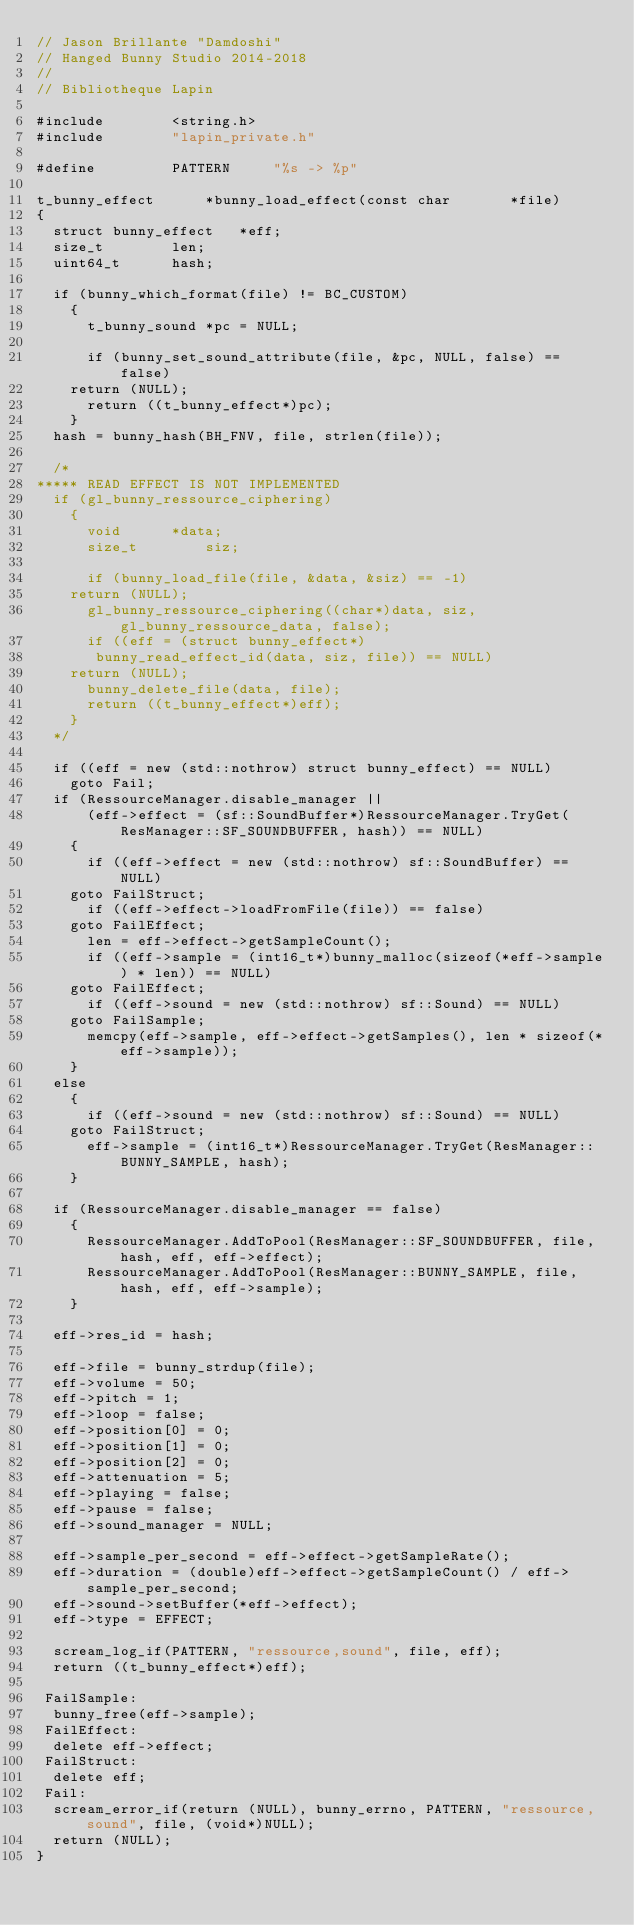<code> <loc_0><loc_0><loc_500><loc_500><_C++_>// Jason Brillante "Damdoshi"
// Hanged Bunny Studio 2014-2018
//
// Bibliotheque Lapin

#include		<string.h>
#include		"lapin_private.h"

#define			PATTERN		"%s -> %p"

t_bunny_effect		*bunny_load_effect(const char		*file)
{
  struct bunny_effect	*eff;
  size_t		len;
  uint64_t		hash;

  if (bunny_which_format(file) != BC_CUSTOM)
    {
      t_bunny_sound	*pc = NULL;

      if (bunny_set_sound_attribute(file, &pc, NULL, false) == false)
	return (NULL);
      return ((t_bunny_effect*)pc);
    }
  hash = bunny_hash(BH_FNV, file, strlen(file));

  /*
***** READ EFFECT IS NOT IMPLEMENTED
  if (gl_bunny_ressource_ciphering)
    {
      void		*data;
      size_t		siz;

      if (bunny_load_file(file, &data, &siz) == -1)
	return (NULL);
      gl_bunny_ressource_ciphering((char*)data, siz, gl_bunny_ressource_data, false);
      if ((eff = (struct bunny_effect*)
	   bunny_read_effect_id(data, siz, file)) == NULL)
	return (NULL);
      bunny_delete_file(data, file);
      return ((t_bunny_effect*)eff);
    }
  */

  if ((eff = new (std::nothrow) struct bunny_effect) == NULL)
    goto Fail;
  if (RessourceManager.disable_manager ||
      (eff->effect = (sf::SoundBuffer*)RessourceManager.TryGet(ResManager::SF_SOUNDBUFFER, hash)) == NULL)
    {
      if ((eff->effect = new (std::nothrow) sf::SoundBuffer) == NULL)
	goto FailStruct;
      if ((eff->effect->loadFromFile(file)) == false)
	goto FailEffect;
      len = eff->effect->getSampleCount();
      if ((eff->sample = (int16_t*)bunny_malloc(sizeof(*eff->sample) * len)) == NULL)
	goto FailEffect;
      if ((eff->sound = new (std::nothrow) sf::Sound) == NULL)
	goto FailSample;
      memcpy(eff->sample, eff->effect->getSamples(), len * sizeof(*eff->sample));
    }
  else
    {
      if ((eff->sound = new (std::nothrow) sf::Sound) == NULL)
	goto FailStruct;
      eff->sample = (int16_t*)RessourceManager.TryGet(ResManager::BUNNY_SAMPLE, hash);
    }

  if (RessourceManager.disable_manager == false)
    {
      RessourceManager.AddToPool(ResManager::SF_SOUNDBUFFER, file, hash, eff, eff->effect);
      RessourceManager.AddToPool(ResManager::BUNNY_SAMPLE, file, hash, eff, eff->sample);
    }

  eff->res_id = hash;

  eff->file = bunny_strdup(file);
  eff->volume = 50;
  eff->pitch = 1;
  eff->loop = false;
  eff->position[0] = 0;
  eff->position[1] = 0;
  eff->position[2] = 0;
  eff->attenuation = 5;
  eff->playing = false;
  eff->pause = false;
  eff->sound_manager = NULL;

  eff->sample_per_second = eff->effect->getSampleRate();
  eff->duration = (double)eff->effect->getSampleCount() / eff->sample_per_second;
  eff->sound->setBuffer(*eff->effect);
  eff->type = EFFECT;

  scream_log_if(PATTERN, "ressource,sound", file, eff);
  return ((t_bunny_effect*)eff);

 FailSample:
  bunny_free(eff->sample);
 FailEffect:
  delete eff->effect;
 FailStruct:
  delete eff;
 Fail:
  scream_error_if(return (NULL), bunny_errno, PATTERN, "ressource,sound", file, (void*)NULL);
  return (NULL);
}
</code> 